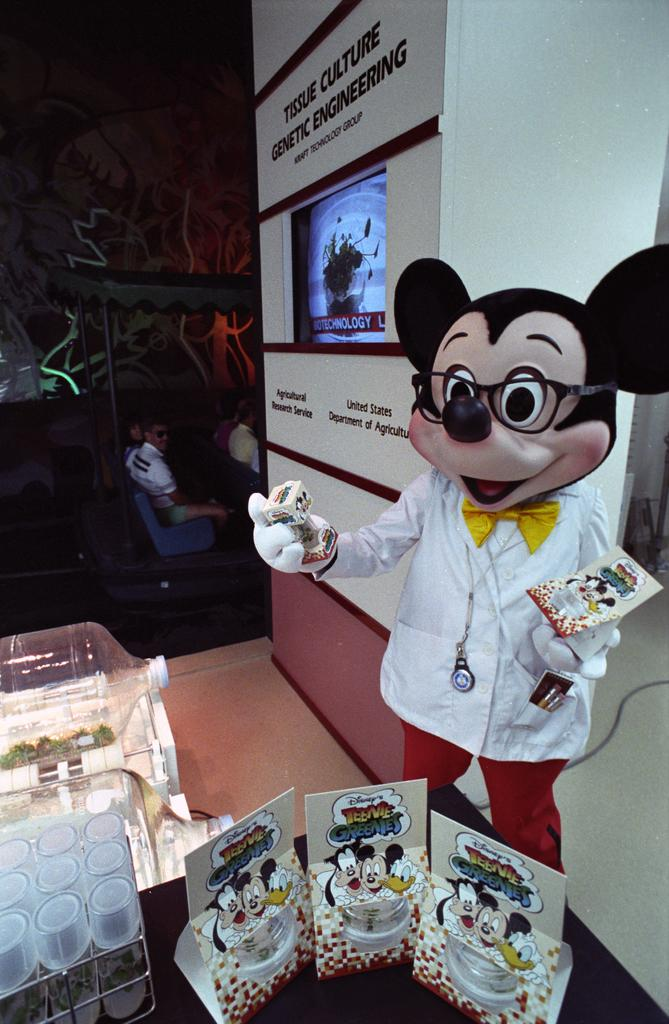What character is represented by the toy on the right side of the image? The Mickey Mouse toy on the right side of the image represents the character Mickey Mouse. What can be seen on the left side of the image? There are persons and glasses on the left side of the image. What is the purpose of the water tin on the left side of the image? The water tin on the left side of the image is likely used for holding water. What is visible in the background of the image? There is a wall and a television in the background of the image. How many cats are laughing in the image? There are no cats present in the image, and therefore no one is laughing. What is the chance of winning a prize in the image? There is no indication of a prize or a chance to win one in the image. 